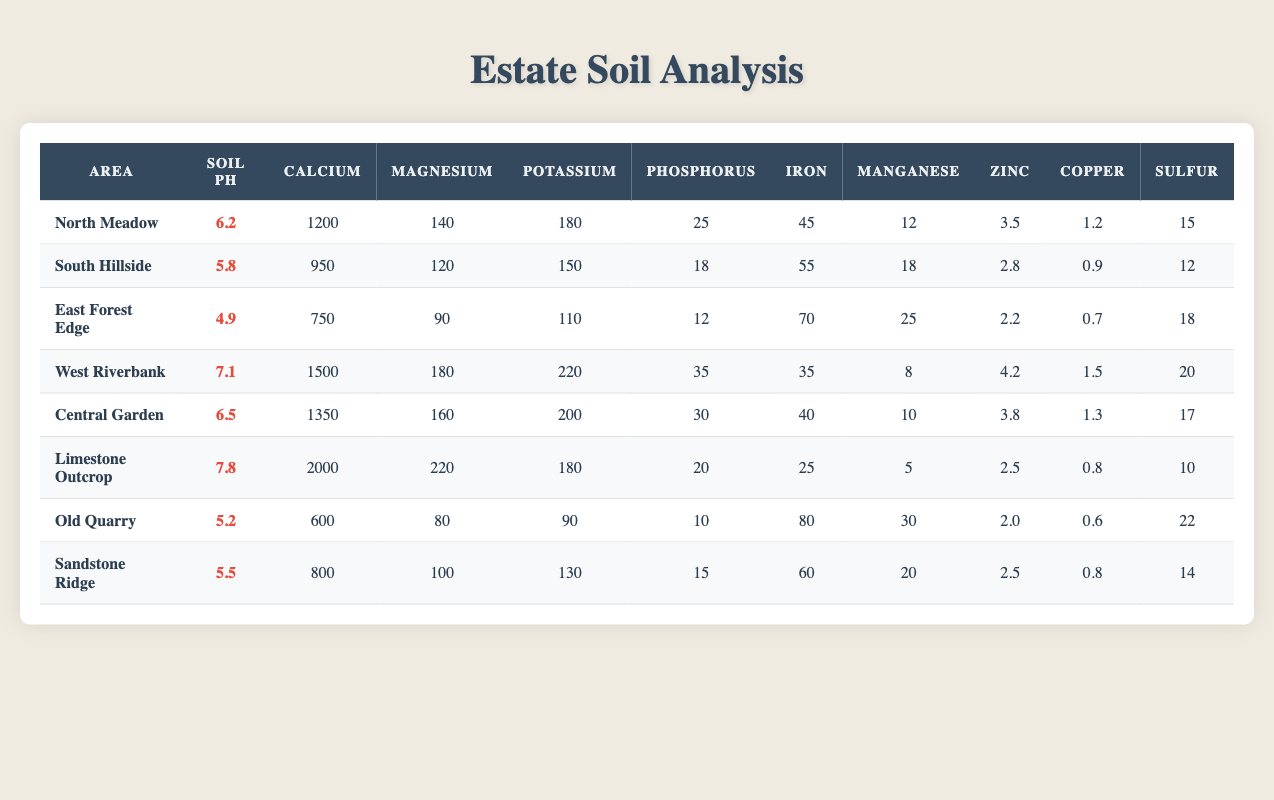What is the soil pH of the West Riverbank? In the table, I locate the row for the West Riverbank area, where the soil pH value is explicitly listed as 7.1.
Answer: 7.1 How much calcium is found in the Central Garden? By checking the Central Garden row in the table, the calcium content is noted to be 1350.
Answer: 1350 Which area has the highest potassium content, and what is that value? Scanning through the potassium values for each area, I find that the West Riverbank has the highest potassium content at 220.
Answer: West Riverbank, 220 Is the soil pH of the East Forest Edge greater than 5.0? The soil pH for the East Forest Edge is listed as 4.9, which is not greater than 5.0. Hence, this statement is false.
Answer: No What is the average magnesium content across all areas? First, I sum the magnesium values: (140 + 120 + 90 + 180 + 160 + 220 + 80 + 100) = 1100. There are 8 areas, so the average is 1100/8 = 137.5.
Answer: 137.5 Does the Old Quarry have more sulfur content than the South Hillside? The Old Quarry has a sulfur value of 22, while the South Hillside has 12. Since 22 is greater than 12, the statement is true.
Answer: Yes How much more iron is present in the East Forest Edge compared to the North Meadow? The iron content in the East Forest Edge is 70 and in the North Meadow is 45. The difference is 70 - 45 = 25.
Answer: 25 What is the total phosphorus content for the North Meadow and Central Garden combined? In the North Meadow, phosphorus is 25, and in the Central Garden, it is 30. Adding these together gives 25 + 30 = 55.
Answer: 55 Which area has the lowest soil pH and what is that value? Looking through the soil pH values, I find that the East Forest Edge has the lowest at 4.9.
Answer: East Forest Edge, 4.9 